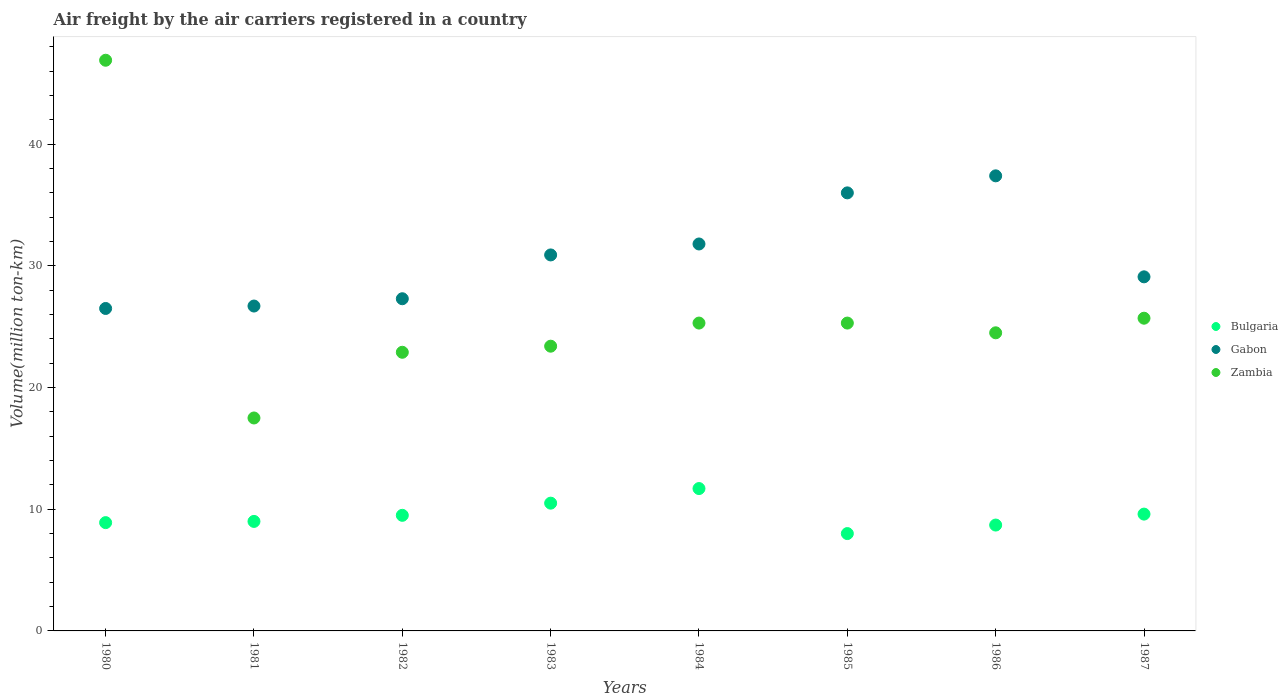Across all years, what is the maximum volume of the air carriers in Gabon?
Your response must be concise. 37.4. Across all years, what is the minimum volume of the air carriers in Zambia?
Your response must be concise. 17.5. In which year was the volume of the air carriers in Gabon maximum?
Give a very brief answer. 1986. In which year was the volume of the air carriers in Zambia minimum?
Provide a succinct answer. 1981. What is the total volume of the air carriers in Gabon in the graph?
Offer a very short reply. 245.7. What is the difference between the volume of the air carriers in Gabon in 1984 and that in 1985?
Provide a short and direct response. -4.2. What is the difference between the volume of the air carriers in Gabon in 1984 and the volume of the air carriers in Zambia in 1986?
Your answer should be very brief. 7.3. What is the average volume of the air carriers in Zambia per year?
Give a very brief answer. 26.44. In the year 1981, what is the difference between the volume of the air carriers in Bulgaria and volume of the air carriers in Gabon?
Give a very brief answer. -17.7. What is the ratio of the volume of the air carriers in Gabon in 1981 to that in 1982?
Your answer should be compact. 0.98. Is the volume of the air carriers in Zambia in 1982 less than that in 1983?
Give a very brief answer. Yes. What is the difference between the highest and the second highest volume of the air carriers in Zambia?
Give a very brief answer. 21.2. What is the difference between the highest and the lowest volume of the air carriers in Zambia?
Offer a very short reply. 29.4. In how many years, is the volume of the air carriers in Gabon greater than the average volume of the air carriers in Gabon taken over all years?
Provide a succinct answer. 4. Is the sum of the volume of the air carriers in Zambia in 1983 and 1986 greater than the maximum volume of the air carriers in Bulgaria across all years?
Your answer should be compact. Yes. Is it the case that in every year, the sum of the volume of the air carriers in Zambia and volume of the air carriers in Bulgaria  is greater than the volume of the air carriers in Gabon?
Keep it short and to the point. No. Does the volume of the air carriers in Bulgaria monotonically increase over the years?
Your response must be concise. No. Is the volume of the air carriers in Gabon strictly greater than the volume of the air carriers in Zambia over the years?
Offer a very short reply. No. Is the volume of the air carriers in Zambia strictly less than the volume of the air carriers in Gabon over the years?
Provide a short and direct response. No. How many dotlines are there?
Offer a terse response. 3. How many years are there in the graph?
Your answer should be very brief. 8. Does the graph contain any zero values?
Your answer should be compact. No. How are the legend labels stacked?
Offer a very short reply. Vertical. What is the title of the graph?
Offer a very short reply. Air freight by the air carriers registered in a country. Does "Central Europe" appear as one of the legend labels in the graph?
Give a very brief answer. No. What is the label or title of the Y-axis?
Ensure brevity in your answer.  Volume(million ton-km). What is the Volume(million ton-km) of Bulgaria in 1980?
Your answer should be very brief. 8.9. What is the Volume(million ton-km) in Gabon in 1980?
Provide a succinct answer. 26.5. What is the Volume(million ton-km) in Zambia in 1980?
Provide a short and direct response. 46.9. What is the Volume(million ton-km) of Gabon in 1981?
Offer a terse response. 26.7. What is the Volume(million ton-km) in Bulgaria in 1982?
Ensure brevity in your answer.  9.5. What is the Volume(million ton-km) in Gabon in 1982?
Give a very brief answer. 27.3. What is the Volume(million ton-km) in Zambia in 1982?
Your response must be concise. 22.9. What is the Volume(million ton-km) in Gabon in 1983?
Offer a very short reply. 30.9. What is the Volume(million ton-km) in Zambia in 1983?
Your answer should be compact. 23.4. What is the Volume(million ton-km) of Bulgaria in 1984?
Your response must be concise. 11.7. What is the Volume(million ton-km) of Gabon in 1984?
Offer a terse response. 31.8. What is the Volume(million ton-km) of Zambia in 1984?
Your answer should be very brief. 25.3. What is the Volume(million ton-km) of Bulgaria in 1985?
Ensure brevity in your answer.  8. What is the Volume(million ton-km) in Zambia in 1985?
Your response must be concise. 25.3. What is the Volume(million ton-km) in Bulgaria in 1986?
Your answer should be very brief. 8.7. What is the Volume(million ton-km) of Gabon in 1986?
Provide a short and direct response. 37.4. What is the Volume(million ton-km) of Bulgaria in 1987?
Your response must be concise. 9.6. What is the Volume(million ton-km) of Gabon in 1987?
Your answer should be compact. 29.1. What is the Volume(million ton-km) in Zambia in 1987?
Your answer should be compact. 25.7. Across all years, what is the maximum Volume(million ton-km) in Bulgaria?
Provide a short and direct response. 11.7. Across all years, what is the maximum Volume(million ton-km) of Gabon?
Provide a short and direct response. 37.4. Across all years, what is the maximum Volume(million ton-km) of Zambia?
Offer a terse response. 46.9. Across all years, what is the minimum Volume(million ton-km) in Bulgaria?
Make the answer very short. 8. What is the total Volume(million ton-km) in Bulgaria in the graph?
Offer a terse response. 75.9. What is the total Volume(million ton-km) of Gabon in the graph?
Give a very brief answer. 245.7. What is the total Volume(million ton-km) of Zambia in the graph?
Provide a succinct answer. 211.5. What is the difference between the Volume(million ton-km) in Zambia in 1980 and that in 1981?
Provide a short and direct response. 29.4. What is the difference between the Volume(million ton-km) of Gabon in 1980 and that in 1982?
Give a very brief answer. -0.8. What is the difference between the Volume(million ton-km) in Zambia in 1980 and that in 1983?
Offer a very short reply. 23.5. What is the difference between the Volume(million ton-km) in Bulgaria in 1980 and that in 1984?
Your response must be concise. -2.8. What is the difference between the Volume(million ton-km) of Gabon in 1980 and that in 1984?
Provide a short and direct response. -5.3. What is the difference between the Volume(million ton-km) in Zambia in 1980 and that in 1984?
Make the answer very short. 21.6. What is the difference between the Volume(million ton-km) of Bulgaria in 1980 and that in 1985?
Provide a short and direct response. 0.9. What is the difference between the Volume(million ton-km) of Gabon in 1980 and that in 1985?
Provide a succinct answer. -9.5. What is the difference between the Volume(million ton-km) in Zambia in 1980 and that in 1985?
Give a very brief answer. 21.6. What is the difference between the Volume(million ton-km) in Bulgaria in 1980 and that in 1986?
Provide a succinct answer. 0.2. What is the difference between the Volume(million ton-km) of Zambia in 1980 and that in 1986?
Your answer should be compact. 22.4. What is the difference between the Volume(million ton-km) of Bulgaria in 1980 and that in 1987?
Provide a succinct answer. -0.7. What is the difference between the Volume(million ton-km) in Zambia in 1980 and that in 1987?
Keep it short and to the point. 21.2. What is the difference between the Volume(million ton-km) in Bulgaria in 1981 and that in 1982?
Ensure brevity in your answer.  -0.5. What is the difference between the Volume(million ton-km) in Gabon in 1981 and that in 1983?
Offer a terse response. -4.2. What is the difference between the Volume(million ton-km) of Zambia in 1981 and that in 1983?
Provide a succinct answer. -5.9. What is the difference between the Volume(million ton-km) in Gabon in 1981 and that in 1984?
Offer a very short reply. -5.1. What is the difference between the Volume(million ton-km) of Zambia in 1981 and that in 1985?
Your response must be concise. -7.8. What is the difference between the Volume(million ton-km) of Gabon in 1981 and that in 1986?
Your answer should be very brief. -10.7. What is the difference between the Volume(million ton-km) of Bulgaria in 1981 and that in 1987?
Make the answer very short. -0.6. What is the difference between the Volume(million ton-km) of Zambia in 1981 and that in 1987?
Make the answer very short. -8.2. What is the difference between the Volume(million ton-km) in Gabon in 1982 and that in 1983?
Provide a short and direct response. -3.6. What is the difference between the Volume(million ton-km) in Bulgaria in 1982 and that in 1984?
Your response must be concise. -2.2. What is the difference between the Volume(million ton-km) in Gabon in 1982 and that in 1984?
Keep it short and to the point. -4.5. What is the difference between the Volume(million ton-km) of Zambia in 1982 and that in 1984?
Give a very brief answer. -2.4. What is the difference between the Volume(million ton-km) in Zambia in 1982 and that in 1985?
Your answer should be very brief. -2.4. What is the difference between the Volume(million ton-km) in Gabon in 1982 and that in 1986?
Give a very brief answer. -10.1. What is the difference between the Volume(million ton-km) of Zambia in 1982 and that in 1986?
Make the answer very short. -1.6. What is the difference between the Volume(million ton-km) in Gabon in 1983 and that in 1984?
Offer a terse response. -0.9. What is the difference between the Volume(million ton-km) of Bulgaria in 1983 and that in 1985?
Your answer should be compact. 2.5. What is the difference between the Volume(million ton-km) in Zambia in 1983 and that in 1985?
Offer a terse response. -1.9. What is the difference between the Volume(million ton-km) in Bulgaria in 1983 and that in 1986?
Provide a succinct answer. 1.8. What is the difference between the Volume(million ton-km) of Zambia in 1983 and that in 1986?
Your answer should be very brief. -1.1. What is the difference between the Volume(million ton-km) in Gabon in 1983 and that in 1987?
Provide a succinct answer. 1.8. What is the difference between the Volume(million ton-km) of Bulgaria in 1984 and that in 1985?
Your answer should be compact. 3.7. What is the difference between the Volume(million ton-km) in Gabon in 1984 and that in 1985?
Give a very brief answer. -4.2. What is the difference between the Volume(million ton-km) in Zambia in 1984 and that in 1985?
Make the answer very short. 0. What is the difference between the Volume(million ton-km) in Bulgaria in 1984 and that in 1986?
Make the answer very short. 3. What is the difference between the Volume(million ton-km) of Bulgaria in 1984 and that in 1987?
Give a very brief answer. 2.1. What is the difference between the Volume(million ton-km) in Zambia in 1984 and that in 1987?
Make the answer very short. -0.4. What is the difference between the Volume(million ton-km) in Gabon in 1985 and that in 1986?
Provide a succinct answer. -1.4. What is the difference between the Volume(million ton-km) in Zambia in 1985 and that in 1986?
Your response must be concise. 0.8. What is the difference between the Volume(million ton-km) of Zambia in 1985 and that in 1987?
Make the answer very short. -0.4. What is the difference between the Volume(million ton-km) in Zambia in 1986 and that in 1987?
Keep it short and to the point. -1.2. What is the difference between the Volume(million ton-km) in Bulgaria in 1980 and the Volume(million ton-km) in Gabon in 1981?
Give a very brief answer. -17.8. What is the difference between the Volume(million ton-km) of Bulgaria in 1980 and the Volume(million ton-km) of Zambia in 1981?
Provide a succinct answer. -8.6. What is the difference between the Volume(million ton-km) of Bulgaria in 1980 and the Volume(million ton-km) of Gabon in 1982?
Your response must be concise. -18.4. What is the difference between the Volume(million ton-km) in Bulgaria in 1980 and the Volume(million ton-km) in Zambia in 1982?
Keep it short and to the point. -14. What is the difference between the Volume(million ton-km) in Gabon in 1980 and the Volume(million ton-km) in Zambia in 1982?
Your answer should be compact. 3.6. What is the difference between the Volume(million ton-km) of Bulgaria in 1980 and the Volume(million ton-km) of Gabon in 1983?
Keep it short and to the point. -22. What is the difference between the Volume(million ton-km) of Bulgaria in 1980 and the Volume(million ton-km) of Gabon in 1984?
Provide a succinct answer. -22.9. What is the difference between the Volume(million ton-km) of Bulgaria in 1980 and the Volume(million ton-km) of Zambia in 1984?
Offer a terse response. -16.4. What is the difference between the Volume(million ton-km) in Bulgaria in 1980 and the Volume(million ton-km) in Gabon in 1985?
Provide a short and direct response. -27.1. What is the difference between the Volume(million ton-km) of Bulgaria in 1980 and the Volume(million ton-km) of Zambia in 1985?
Your answer should be compact. -16.4. What is the difference between the Volume(million ton-km) in Gabon in 1980 and the Volume(million ton-km) in Zambia in 1985?
Ensure brevity in your answer.  1.2. What is the difference between the Volume(million ton-km) of Bulgaria in 1980 and the Volume(million ton-km) of Gabon in 1986?
Provide a short and direct response. -28.5. What is the difference between the Volume(million ton-km) of Bulgaria in 1980 and the Volume(million ton-km) of Zambia in 1986?
Your response must be concise. -15.6. What is the difference between the Volume(million ton-km) in Gabon in 1980 and the Volume(million ton-km) in Zambia in 1986?
Offer a terse response. 2. What is the difference between the Volume(million ton-km) of Bulgaria in 1980 and the Volume(million ton-km) of Gabon in 1987?
Give a very brief answer. -20.2. What is the difference between the Volume(million ton-km) in Bulgaria in 1980 and the Volume(million ton-km) in Zambia in 1987?
Offer a very short reply. -16.8. What is the difference between the Volume(million ton-km) in Gabon in 1980 and the Volume(million ton-km) in Zambia in 1987?
Provide a succinct answer. 0.8. What is the difference between the Volume(million ton-km) of Bulgaria in 1981 and the Volume(million ton-km) of Gabon in 1982?
Offer a terse response. -18.3. What is the difference between the Volume(million ton-km) of Gabon in 1981 and the Volume(million ton-km) of Zambia in 1982?
Your response must be concise. 3.8. What is the difference between the Volume(million ton-km) in Bulgaria in 1981 and the Volume(million ton-km) in Gabon in 1983?
Make the answer very short. -21.9. What is the difference between the Volume(million ton-km) in Bulgaria in 1981 and the Volume(million ton-km) in Zambia in 1983?
Give a very brief answer. -14.4. What is the difference between the Volume(million ton-km) of Gabon in 1981 and the Volume(million ton-km) of Zambia in 1983?
Provide a short and direct response. 3.3. What is the difference between the Volume(million ton-km) in Bulgaria in 1981 and the Volume(million ton-km) in Gabon in 1984?
Make the answer very short. -22.8. What is the difference between the Volume(million ton-km) of Bulgaria in 1981 and the Volume(million ton-km) of Zambia in 1984?
Make the answer very short. -16.3. What is the difference between the Volume(million ton-km) in Bulgaria in 1981 and the Volume(million ton-km) in Gabon in 1985?
Offer a terse response. -27. What is the difference between the Volume(million ton-km) in Bulgaria in 1981 and the Volume(million ton-km) in Zambia in 1985?
Offer a terse response. -16.3. What is the difference between the Volume(million ton-km) of Bulgaria in 1981 and the Volume(million ton-km) of Gabon in 1986?
Your answer should be very brief. -28.4. What is the difference between the Volume(million ton-km) of Bulgaria in 1981 and the Volume(million ton-km) of Zambia in 1986?
Give a very brief answer. -15.5. What is the difference between the Volume(million ton-km) of Gabon in 1981 and the Volume(million ton-km) of Zambia in 1986?
Make the answer very short. 2.2. What is the difference between the Volume(million ton-km) of Bulgaria in 1981 and the Volume(million ton-km) of Gabon in 1987?
Provide a short and direct response. -20.1. What is the difference between the Volume(million ton-km) in Bulgaria in 1981 and the Volume(million ton-km) in Zambia in 1987?
Your answer should be compact. -16.7. What is the difference between the Volume(million ton-km) in Gabon in 1981 and the Volume(million ton-km) in Zambia in 1987?
Your response must be concise. 1. What is the difference between the Volume(million ton-km) in Bulgaria in 1982 and the Volume(million ton-km) in Gabon in 1983?
Make the answer very short. -21.4. What is the difference between the Volume(million ton-km) in Gabon in 1982 and the Volume(million ton-km) in Zambia in 1983?
Give a very brief answer. 3.9. What is the difference between the Volume(million ton-km) of Bulgaria in 1982 and the Volume(million ton-km) of Gabon in 1984?
Provide a succinct answer. -22.3. What is the difference between the Volume(million ton-km) of Bulgaria in 1982 and the Volume(million ton-km) of Zambia in 1984?
Your answer should be compact. -15.8. What is the difference between the Volume(million ton-km) in Bulgaria in 1982 and the Volume(million ton-km) in Gabon in 1985?
Your answer should be compact. -26.5. What is the difference between the Volume(million ton-km) of Bulgaria in 1982 and the Volume(million ton-km) of Zambia in 1985?
Ensure brevity in your answer.  -15.8. What is the difference between the Volume(million ton-km) of Bulgaria in 1982 and the Volume(million ton-km) of Gabon in 1986?
Your answer should be very brief. -27.9. What is the difference between the Volume(million ton-km) of Bulgaria in 1982 and the Volume(million ton-km) of Zambia in 1986?
Ensure brevity in your answer.  -15. What is the difference between the Volume(million ton-km) in Bulgaria in 1982 and the Volume(million ton-km) in Gabon in 1987?
Keep it short and to the point. -19.6. What is the difference between the Volume(million ton-km) in Bulgaria in 1982 and the Volume(million ton-km) in Zambia in 1987?
Your response must be concise. -16.2. What is the difference between the Volume(million ton-km) in Gabon in 1982 and the Volume(million ton-km) in Zambia in 1987?
Provide a short and direct response. 1.6. What is the difference between the Volume(million ton-km) of Bulgaria in 1983 and the Volume(million ton-km) of Gabon in 1984?
Your answer should be very brief. -21.3. What is the difference between the Volume(million ton-km) in Bulgaria in 1983 and the Volume(million ton-km) in Zambia in 1984?
Offer a terse response. -14.8. What is the difference between the Volume(million ton-km) in Bulgaria in 1983 and the Volume(million ton-km) in Gabon in 1985?
Offer a terse response. -25.5. What is the difference between the Volume(million ton-km) in Bulgaria in 1983 and the Volume(million ton-km) in Zambia in 1985?
Offer a very short reply. -14.8. What is the difference between the Volume(million ton-km) of Gabon in 1983 and the Volume(million ton-km) of Zambia in 1985?
Your answer should be compact. 5.6. What is the difference between the Volume(million ton-km) of Bulgaria in 1983 and the Volume(million ton-km) of Gabon in 1986?
Make the answer very short. -26.9. What is the difference between the Volume(million ton-km) in Bulgaria in 1983 and the Volume(million ton-km) in Zambia in 1986?
Keep it short and to the point. -14. What is the difference between the Volume(million ton-km) in Bulgaria in 1983 and the Volume(million ton-km) in Gabon in 1987?
Keep it short and to the point. -18.6. What is the difference between the Volume(million ton-km) in Bulgaria in 1983 and the Volume(million ton-km) in Zambia in 1987?
Provide a short and direct response. -15.2. What is the difference between the Volume(million ton-km) in Gabon in 1983 and the Volume(million ton-km) in Zambia in 1987?
Make the answer very short. 5.2. What is the difference between the Volume(million ton-km) in Bulgaria in 1984 and the Volume(million ton-km) in Gabon in 1985?
Keep it short and to the point. -24.3. What is the difference between the Volume(million ton-km) in Bulgaria in 1984 and the Volume(million ton-km) in Zambia in 1985?
Offer a terse response. -13.6. What is the difference between the Volume(million ton-km) in Bulgaria in 1984 and the Volume(million ton-km) in Gabon in 1986?
Ensure brevity in your answer.  -25.7. What is the difference between the Volume(million ton-km) of Bulgaria in 1984 and the Volume(million ton-km) of Zambia in 1986?
Give a very brief answer. -12.8. What is the difference between the Volume(million ton-km) in Gabon in 1984 and the Volume(million ton-km) in Zambia in 1986?
Give a very brief answer. 7.3. What is the difference between the Volume(million ton-km) in Bulgaria in 1984 and the Volume(million ton-km) in Gabon in 1987?
Ensure brevity in your answer.  -17.4. What is the difference between the Volume(million ton-km) in Bulgaria in 1985 and the Volume(million ton-km) in Gabon in 1986?
Provide a short and direct response. -29.4. What is the difference between the Volume(million ton-km) of Bulgaria in 1985 and the Volume(million ton-km) of Zambia in 1986?
Offer a terse response. -16.5. What is the difference between the Volume(million ton-km) in Gabon in 1985 and the Volume(million ton-km) in Zambia in 1986?
Keep it short and to the point. 11.5. What is the difference between the Volume(million ton-km) in Bulgaria in 1985 and the Volume(million ton-km) in Gabon in 1987?
Your answer should be compact. -21.1. What is the difference between the Volume(million ton-km) of Bulgaria in 1985 and the Volume(million ton-km) of Zambia in 1987?
Provide a short and direct response. -17.7. What is the difference between the Volume(million ton-km) of Gabon in 1985 and the Volume(million ton-km) of Zambia in 1987?
Give a very brief answer. 10.3. What is the difference between the Volume(million ton-km) in Bulgaria in 1986 and the Volume(million ton-km) in Gabon in 1987?
Provide a short and direct response. -20.4. What is the difference between the Volume(million ton-km) of Gabon in 1986 and the Volume(million ton-km) of Zambia in 1987?
Give a very brief answer. 11.7. What is the average Volume(million ton-km) of Bulgaria per year?
Your response must be concise. 9.49. What is the average Volume(million ton-km) in Gabon per year?
Keep it short and to the point. 30.71. What is the average Volume(million ton-km) in Zambia per year?
Give a very brief answer. 26.44. In the year 1980, what is the difference between the Volume(million ton-km) in Bulgaria and Volume(million ton-km) in Gabon?
Ensure brevity in your answer.  -17.6. In the year 1980, what is the difference between the Volume(million ton-km) of Bulgaria and Volume(million ton-km) of Zambia?
Offer a terse response. -38. In the year 1980, what is the difference between the Volume(million ton-km) in Gabon and Volume(million ton-km) in Zambia?
Your answer should be very brief. -20.4. In the year 1981, what is the difference between the Volume(million ton-km) in Bulgaria and Volume(million ton-km) in Gabon?
Your answer should be very brief. -17.7. In the year 1981, what is the difference between the Volume(million ton-km) in Bulgaria and Volume(million ton-km) in Zambia?
Provide a succinct answer. -8.5. In the year 1982, what is the difference between the Volume(million ton-km) of Bulgaria and Volume(million ton-km) of Gabon?
Offer a terse response. -17.8. In the year 1982, what is the difference between the Volume(million ton-km) of Bulgaria and Volume(million ton-km) of Zambia?
Provide a short and direct response. -13.4. In the year 1982, what is the difference between the Volume(million ton-km) of Gabon and Volume(million ton-km) of Zambia?
Provide a short and direct response. 4.4. In the year 1983, what is the difference between the Volume(million ton-km) in Bulgaria and Volume(million ton-km) in Gabon?
Offer a terse response. -20.4. In the year 1984, what is the difference between the Volume(million ton-km) of Bulgaria and Volume(million ton-km) of Gabon?
Offer a very short reply. -20.1. In the year 1984, what is the difference between the Volume(million ton-km) of Bulgaria and Volume(million ton-km) of Zambia?
Your answer should be very brief. -13.6. In the year 1984, what is the difference between the Volume(million ton-km) of Gabon and Volume(million ton-km) of Zambia?
Offer a terse response. 6.5. In the year 1985, what is the difference between the Volume(million ton-km) in Bulgaria and Volume(million ton-km) in Gabon?
Your response must be concise. -28. In the year 1985, what is the difference between the Volume(million ton-km) of Bulgaria and Volume(million ton-km) of Zambia?
Give a very brief answer. -17.3. In the year 1985, what is the difference between the Volume(million ton-km) of Gabon and Volume(million ton-km) of Zambia?
Provide a succinct answer. 10.7. In the year 1986, what is the difference between the Volume(million ton-km) of Bulgaria and Volume(million ton-km) of Gabon?
Provide a succinct answer. -28.7. In the year 1986, what is the difference between the Volume(million ton-km) in Bulgaria and Volume(million ton-km) in Zambia?
Ensure brevity in your answer.  -15.8. In the year 1986, what is the difference between the Volume(million ton-km) in Gabon and Volume(million ton-km) in Zambia?
Ensure brevity in your answer.  12.9. In the year 1987, what is the difference between the Volume(million ton-km) in Bulgaria and Volume(million ton-km) in Gabon?
Make the answer very short. -19.5. In the year 1987, what is the difference between the Volume(million ton-km) of Bulgaria and Volume(million ton-km) of Zambia?
Your answer should be very brief. -16.1. In the year 1987, what is the difference between the Volume(million ton-km) in Gabon and Volume(million ton-km) in Zambia?
Provide a succinct answer. 3.4. What is the ratio of the Volume(million ton-km) in Bulgaria in 1980 to that in 1981?
Your answer should be very brief. 0.99. What is the ratio of the Volume(million ton-km) in Gabon in 1980 to that in 1981?
Provide a short and direct response. 0.99. What is the ratio of the Volume(million ton-km) in Zambia in 1980 to that in 1981?
Offer a terse response. 2.68. What is the ratio of the Volume(million ton-km) in Bulgaria in 1980 to that in 1982?
Offer a very short reply. 0.94. What is the ratio of the Volume(million ton-km) of Gabon in 1980 to that in 1982?
Provide a succinct answer. 0.97. What is the ratio of the Volume(million ton-km) of Zambia in 1980 to that in 1982?
Keep it short and to the point. 2.05. What is the ratio of the Volume(million ton-km) in Bulgaria in 1980 to that in 1983?
Ensure brevity in your answer.  0.85. What is the ratio of the Volume(million ton-km) in Gabon in 1980 to that in 1983?
Make the answer very short. 0.86. What is the ratio of the Volume(million ton-km) of Zambia in 1980 to that in 1983?
Keep it short and to the point. 2. What is the ratio of the Volume(million ton-km) in Bulgaria in 1980 to that in 1984?
Ensure brevity in your answer.  0.76. What is the ratio of the Volume(million ton-km) of Zambia in 1980 to that in 1984?
Offer a terse response. 1.85. What is the ratio of the Volume(million ton-km) of Bulgaria in 1980 to that in 1985?
Keep it short and to the point. 1.11. What is the ratio of the Volume(million ton-km) of Gabon in 1980 to that in 1985?
Offer a very short reply. 0.74. What is the ratio of the Volume(million ton-km) of Zambia in 1980 to that in 1985?
Provide a short and direct response. 1.85. What is the ratio of the Volume(million ton-km) of Gabon in 1980 to that in 1986?
Give a very brief answer. 0.71. What is the ratio of the Volume(million ton-km) in Zambia in 1980 to that in 1986?
Make the answer very short. 1.91. What is the ratio of the Volume(million ton-km) of Bulgaria in 1980 to that in 1987?
Your response must be concise. 0.93. What is the ratio of the Volume(million ton-km) of Gabon in 1980 to that in 1987?
Offer a very short reply. 0.91. What is the ratio of the Volume(million ton-km) of Zambia in 1980 to that in 1987?
Provide a short and direct response. 1.82. What is the ratio of the Volume(million ton-km) of Gabon in 1981 to that in 1982?
Provide a short and direct response. 0.98. What is the ratio of the Volume(million ton-km) of Zambia in 1981 to that in 1982?
Make the answer very short. 0.76. What is the ratio of the Volume(million ton-km) in Gabon in 1981 to that in 1983?
Your answer should be compact. 0.86. What is the ratio of the Volume(million ton-km) in Zambia in 1981 to that in 1983?
Your answer should be compact. 0.75. What is the ratio of the Volume(million ton-km) of Bulgaria in 1981 to that in 1984?
Make the answer very short. 0.77. What is the ratio of the Volume(million ton-km) in Gabon in 1981 to that in 1984?
Offer a terse response. 0.84. What is the ratio of the Volume(million ton-km) in Zambia in 1981 to that in 1984?
Ensure brevity in your answer.  0.69. What is the ratio of the Volume(million ton-km) of Bulgaria in 1981 to that in 1985?
Provide a short and direct response. 1.12. What is the ratio of the Volume(million ton-km) of Gabon in 1981 to that in 1985?
Offer a very short reply. 0.74. What is the ratio of the Volume(million ton-km) in Zambia in 1981 to that in 1985?
Provide a succinct answer. 0.69. What is the ratio of the Volume(million ton-km) of Bulgaria in 1981 to that in 1986?
Ensure brevity in your answer.  1.03. What is the ratio of the Volume(million ton-km) in Gabon in 1981 to that in 1986?
Make the answer very short. 0.71. What is the ratio of the Volume(million ton-km) of Zambia in 1981 to that in 1986?
Make the answer very short. 0.71. What is the ratio of the Volume(million ton-km) of Bulgaria in 1981 to that in 1987?
Offer a very short reply. 0.94. What is the ratio of the Volume(million ton-km) in Gabon in 1981 to that in 1987?
Offer a very short reply. 0.92. What is the ratio of the Volume(million ton-km) in Zambia in 1981 to that in 1987?
Your response must be concise. 0.68. What is the ratio of the Volume(million ton-km) in Bulgaria in 1982 to that in 1983?
Give a very brief answer. 0.9. What is the ratio of the Volume(million ton-km) of Gabon in 1982 to that in 1983?
Your answer should be very brief. 0.88. What is the ratio of the Volume(million ton-km) of Zambia in 1982 to that in 1983?
Give a very brief answer. 0.98. What is the ratio of the Volume(million ton-km) in Bulgaria in 1982 to that in 1984?
Ensure brevity in your answer.  0.81. What is the ratio of the Volume(million ton-km) of Gabon in 1982 to that in 1984?
Ensure brevity in your answer.  0.86. What is the ratio of the Volume(million ton-km) in Zambia in 1982 to that in 1984?
Your answer should be very brief. 0.91. What is the ratio of the Volume(million ton-km) in Bulgaria in 1982 to that in 1985?
Offer a very short reply. 1.19. What is the ratio of the Volume(million ton-km) in Gabon in 1982 to that in 1985?
Make the answer very short. 0.76. What is the ratio of the Volume(million ton-km) in Zambia in 1982 to that in 1985?
Your answer should be compact. 0.91. What is the ratio of the Volume(million ton-km) in Bulgaria in 1982 to that in 1986?
Offer a terse response. 1.09. What is the ratio of the Volume(million ton-km) in Gabon in 1982 to that in 1986?
Your answer should be compact. 0.73. What is the ratio of the Volume(million ton-km) in Zambia in 1982 to that in 1986?
Your answer should be very brief. 0.93. What is the ratio of the Volume(million ton-km) of Gabon in 1982 to that in 1987?
Your answer should be very brief. 0.94. What is the ratio of the Volume(million ton-km) in Zambia in 1982 to that in 1987?
Make the answer very short. 0.89. What is the ratio of the Volume(million ton-km) of Bulgaria in 1983 to that in 1984?
Ensure brevity in your answer.  0.9. What is the ratio of the Volume(million ton-km) in Gabon in 1983 to that in 1984?
Keep it short and to the point. 0.97. What is the ratio of the Volume(million ton-km) in Zambia in 1983 to that in 1984?
Your answer should be very brief. 0.92. What is the ratio of the Volume(million ton-km) of Bulgaria in 1983 to that in 1985?
Keep it short and to the point. 1.31. What is the ratio of the Volume(million ton-km) in Gabon in 1983 to that in 1985?
Provide a succinct answer. 0.86. What is the ratio of the Volume(million ton-km) in Zambia in 1983 to that in 1985?
Offer a very short reply. 0.92. What is the ratio of the Volume(million ton-km) in Bulgaria in 1983 to that in 1986?
Your answer should be compact. 1.21. What is the ratio of the Volume(million ton-km) of Gabon in 1983 to that in 1986?
Ensure brevity in your answer.  0.83. What is the ratio of the Volume(million ton-km) of Zambia in 1983 to that in 1986?
Offer a very short reply. 0.96. What is the ratio of the Volume(million ton-km) in Bulgaria in 1983 to that in 1987?
Provide a short and direct response. 1.09. What is the ratio of the Volume(million ton-km) of Gabon in 1983 to that in 1987?
Offer a very short reply. 1.06. What is the ratio of the Volume(million ton-km) in Zambia in 1983 to that in 1987?
Offer a very short reply. 0.91. What is the ratio of the Volume(million ton-km) in Bulgaria in 1984 to that in 1985?
Your answer should be compact. 1.46. What is the ratio of the Volume(million ton-km) in Gabon in 1984 to that in 1985?
Your answer should be very brief. 0.88. What is the ratio of the Volume(million ton-km) in Bulgaria in 1984 to that in 1986?
Your answer should be compact. 1.34. What is the ratio of the Volume(million ton-km) in Gabon in 1984 to that in 1986?
Provide a short and direct response. 0.85. What is the ratio of the Volume(million ton-km) in Zambia in 1984 to that in 1986?
Make the answer very short. 1.03. What is the ratio of the Volume(million ton-km) in Bulgaria in 1984 to that in 1987?
Offer a very short reply. 1.22. What is the ratio of the Volume(million ton-km) of Gabon in 1984 to that in 1987?
Your answer should be compact. 1.09. What is the ratio of the Volume(million ton-km) in Zambia in 1984 to that in 1987?
Your answer should be compact. 0.98. What is the ratio of the Volume(million ton-km) in Bulgaria in 1985 to that in 1986?
Your answer should be very brief. 0.92. What is the ratio of the Volume(million ton-km) in Gabon in 1985 to that in 1986?
Make the answer very short. 0.96. What is the ratio of the Volume(million ton-km) in Zambia in 1985 to that in 1986?
Provide a succinct answer. 1.03. What is the ratio of the Volume(million ton-km) in Bulgaria in 1985 to that in 1987?
Give a very brief answer. 0.83. What is the ratio of the Volume(million ton-km) in Gabon in 1985 to that in 1987?
Provide a short and direct response. 1.24. What is the ratio of the Volume(million ton-km) of Zambia in 1985 to that in 1987?
Offer a very short reply. 0.98. What is the ratio of the Volume(million ton-km) in Bulgaria in 1986 to that in 1987?
Offer a terse response. 0.91. What is the ratio of the Volume(million ton-km) of Gabon in 1986 to that in 1987?
Offer a terse response. 1.29. What is the ratio of the Volume(million ton-km) of Zambia in 1986 to that in 1987?
Make the answer very short. 0.95. What is the difference between the highest and the second highest Volume(million ton-km) of Zambia?
Your answer should be compact. 21.2. What is the difference between the highest and the lowest Volume(million ton-km) in Zambia?
Offer a very short reply. 29.4. 